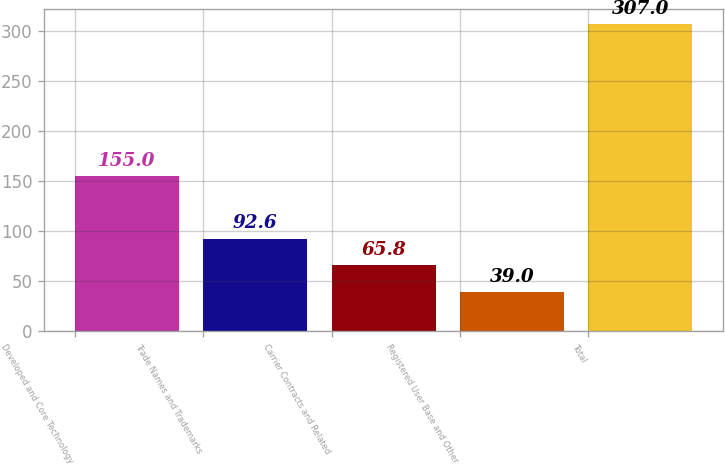Convert chart. <chart><loc_0><loc_0><loc_500><loc_500><bar_chart><fcel>Developed and Core Technology<fcel>Trade Names and Trademarks<fcel>Carrier Contracts and Related<fcel>Registered User Base and Other<fcel>Total<nl><fcel>155<fcel>92.6<fcel>65.8<fcel>39<fcel>307<nl></chart> 